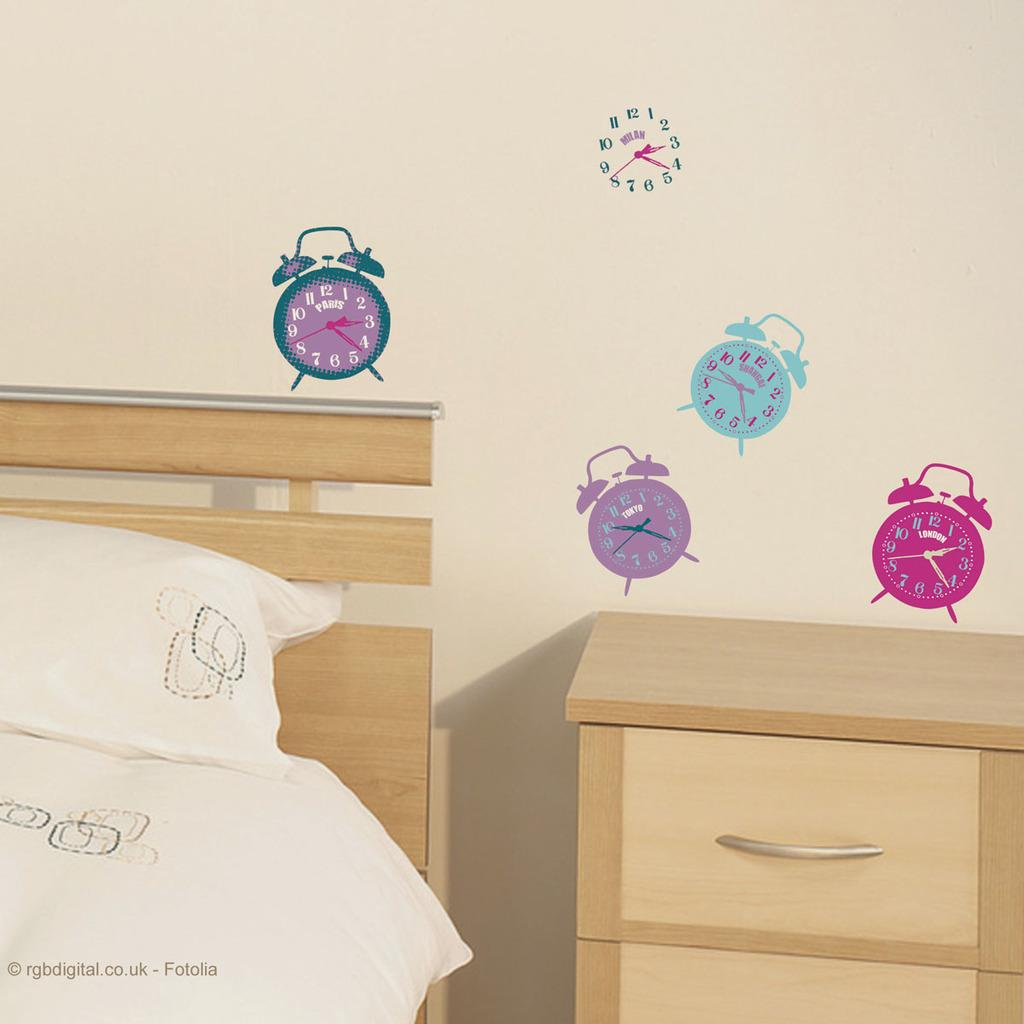<image>
Relay a brief, clear account of the picture shown. a bedroom photo with a label at the bottom that says 'rgbdigital.co.uk -fotolia' 